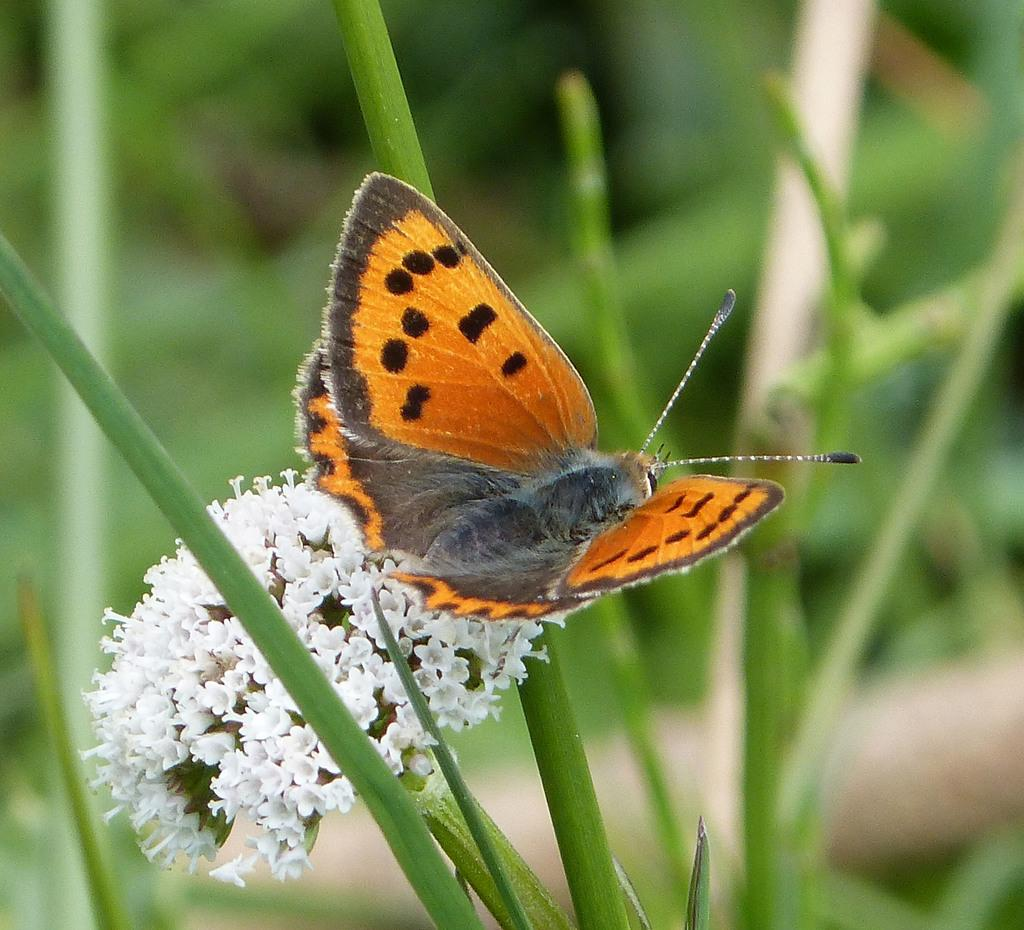What is the main subject in the foreground of the image? There is a flower in the foreground of the image. Is there anything interacting with the flower? Yes, there is a butterfly on the flower. What else can be seen in the foreground of the image? There are plants in the foreground of the image. What is visible in the background of the image? There are plants in the background of the image. What type of stone is being played by the grandmother in the image? There is no stone or grandmother present in the image; it features a flower and a butterfly. 